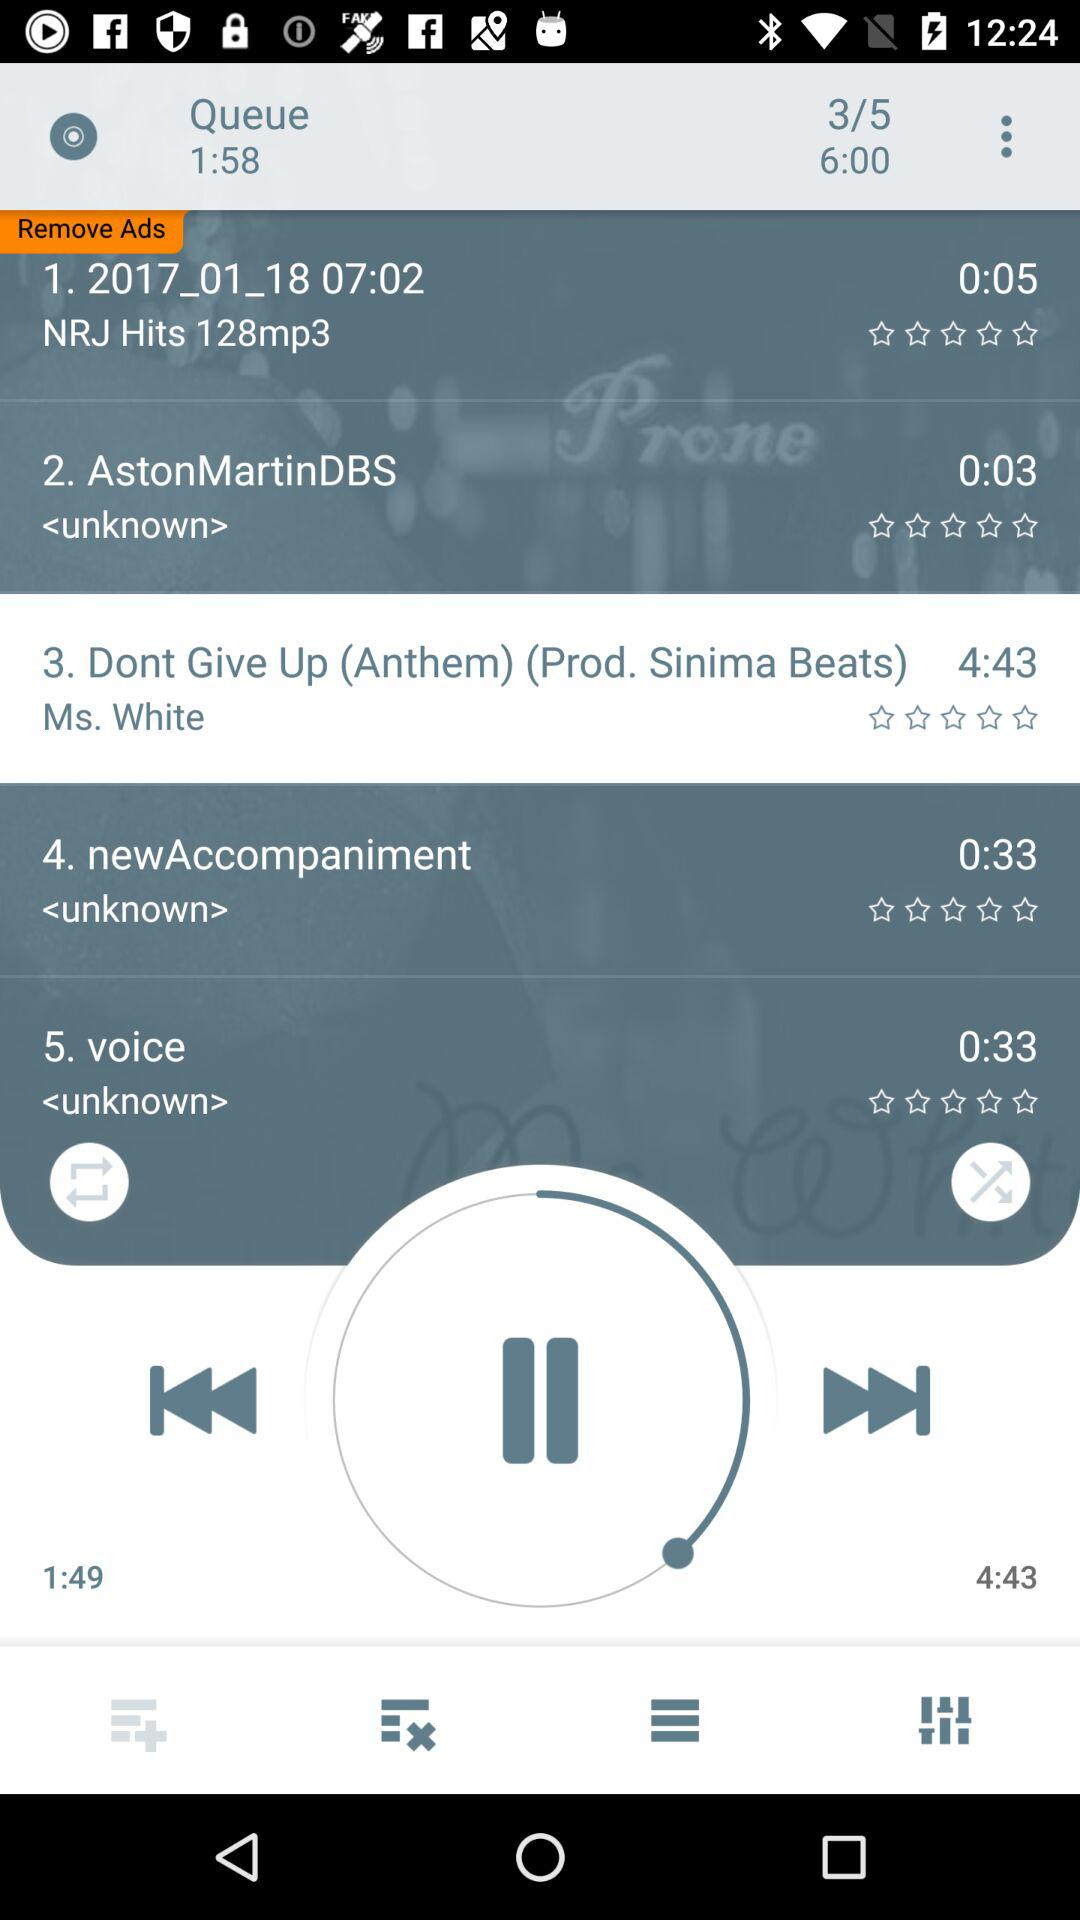How many songs are in the queue?
Answer the question using a single word or phrase. 5 